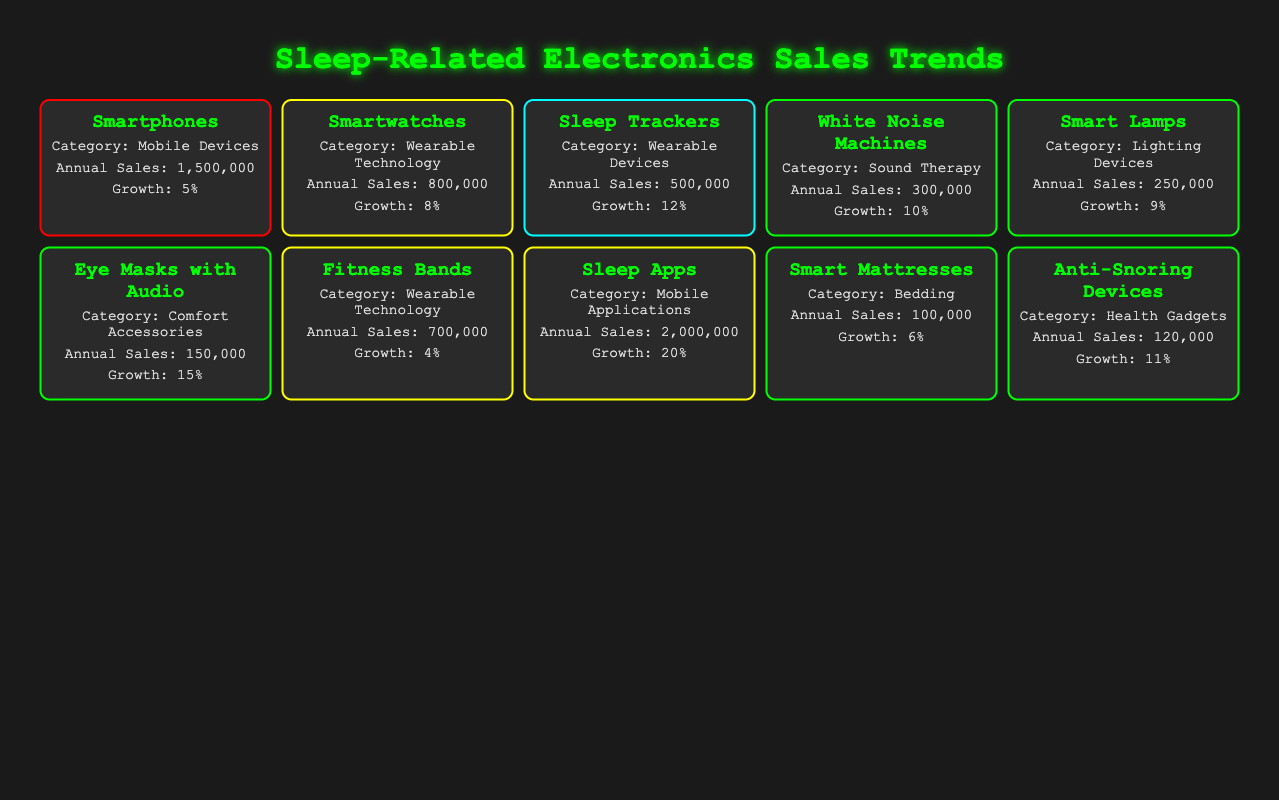What is the element with the highest average annual sales? By looking at the Annual Sales column in the table, I see that Smartphones have the highest sales figure at 1,500,000 units.
Answer: Smartphones How many categories are represented in the table? The table lists the categories for each product. There are eight unique categories: Mobile Devices, Wearable Technology, Wearable Devices, Sound Therapy, Lighting Devices, Comfort Accessories, Mobile Applications, and Bedding.
Answer: Eight Which product has the highest growth rate? Checking the Growth Rate column, I find that Sleep Apps have the highest growth rate at 20%.
Answer: Sleep Apps What is the average annual sales of all products listed? To calculate the average, I sum the Average Annual Sales: (1,500,000 + 800,000 + 500,000 + 300,000 + 250,000 + 150,000 + 700,000 + 2,000,000 + 100,000 + 120,000) = 6,620,000. Dividing by 10 (the number of products) gives 662,000.
Answer: 662,000 Are there more devices categorized as Wearable Technology than as Mobile Applications? There are three devices categorized as Wearable Technology (Smartwatches, Fitness Bands, Sleep Trackers) and two in Mobile Applications (Sleep Apps). Therefore, Yes, there are more Wearable Technology devices.
Answer: Yes Which devices have a positive impact on sleep and also have a growth rate greater than 10%? From the table, I see that the devices with a positive sleep impact and growth rate greater than 10% are Eye Masks with Audio (15%) and Sleep Apps (20%).
Answer: Eye Masks with Audio, Sleep Apps What is the total average annual sales for devices with a high impact on sleep? Identifying high-impact devices: Smartphones (1,500,000) is the only device listed with high sleep impact. So the total average is just 1,500,000.
Answer: 1,500,000 Is the average annual sales of Smart Mattresses higher than that of Anti-Snoring Devices? Smart Mattresses have annual sales of 100,000 while Anti-Snoring Devices have 120,000. Therefore, No, Smart Mattresses do not have higher sales.
Answer: No 